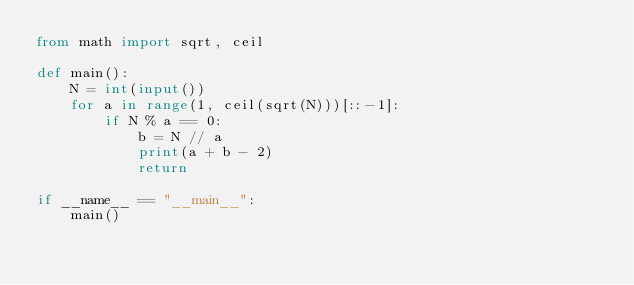Convert code to text. <code><loc_0><loc_0><loc_500><loc_500><_Python_>from math import sqrt, ceil

def main():
    N = int(input())
    for a in range(1, ceil(sqrt(N)))[::-1]:
        if N % a == 0:
            b = N // a
            print(a + b - 2)
            return

if __name__ == "__main__":
    main()</code> 